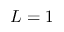Convert formula to latex. <formula><loc_0><loc_0><loc_500><loc_500>L = 1</formula> 